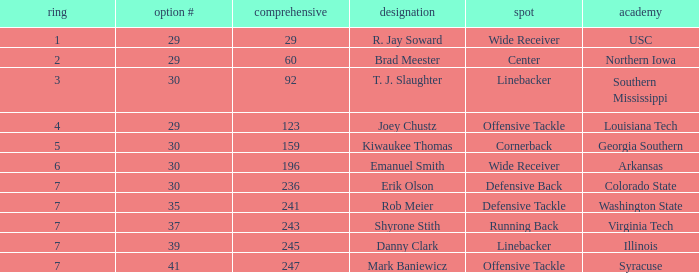What is the lowest Round with Overall of 247 and pick less than 41? None. 